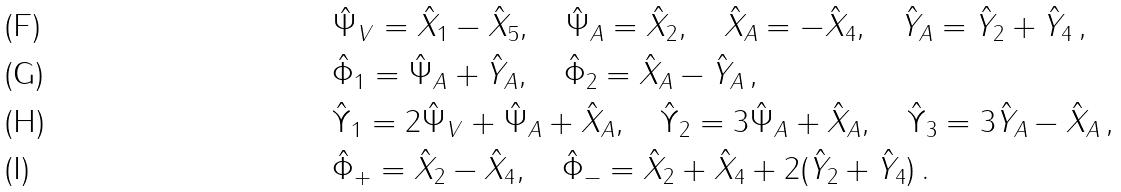<formula> <loc_0><loc_0><loc_500><loc_500>& \hat { \Psi } _ { V } = \hat { X } _ { 1 } - \hat { X } _ { 5 } , \quad \hat { \Psi } _ { A } = \hat { X } _ { 2 } , \quad \hat { X } _ { A } = - \hat { X } _ { 4 } , \quad \hat { Y } _ { A } = \hat { Y } _ { 2 } + \hat { Y } _ { 4 } \, , \\ & \hat { \Phi } _ { 1 } = \hat { \Psi } _ { A } + \hat { Y } _ { A } , \quad \hat { \Phi } _ { 2 } = \hat { X } _ { A } - \hat { Y } _ { A } \, , \\ & \hat { \Upsilon } _ { 1 } = 2 \hat { \Psi } _ { V } + \hat { \Psi } _ { A } + \hat { X } _ { A } , \quad \hat { \Upsilon } _ { 2 } = 3 \hat { \Psi } _ { A } + \hat { X } _ { A } , \quad \hat { \Upsilon } _ { 3 } = 3 \hat { Y } _ { A } - \hat { X } _ { A } \, , \\ & \hat { \Phi } _ { + } = \hat { X } _ { 2 } - \hat { X } _ { 4 } , \quad \hat { \Phi } _ { - } = \hat { X } _ { 2 } + \hat { X } _ { 4 } + 2 ( \hat { Y } _ { 2 } + \hat { Y } _ { 4 } ) \, .</formula> 